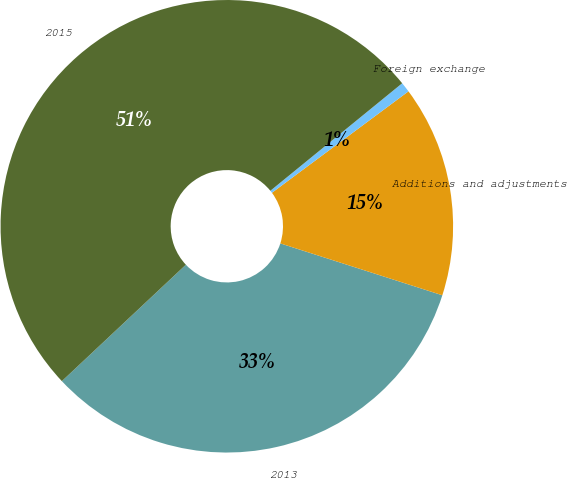Convert chart. <chart><loc_0><loc_0><loc_500><loc_500><pie_chart><fcel>2013<fcel>Additions and adjustments<fcel>Foreign exchange<fcel>2015<nl><fcel>33.07%<fcel>15.1%<fcel>0.72%<fcel>51.11%<nl></chart> 